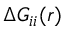<formula> <loc_0><loc_0><loc_500><loc_500>\Delta G _ { i i } ( r )</formula> 